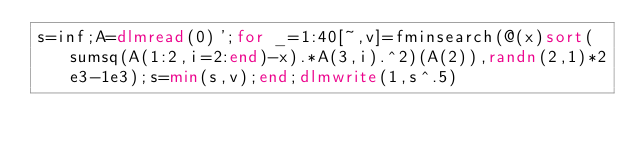Convert code to text. <code><loc_0><loc_0><loc_500><loc_500><_Octave_>s=inf;A=dlmread(0)';for _=1:40[~,v]=fminsearch(@(x)sort(sumsq(A(1:2,i=2:end)-x).*A(3,i).^2)(A(2)),randn(2,1)*2e3-1e3);s=min(s,v);end;dlmwrite(1,s^.5)</code> 